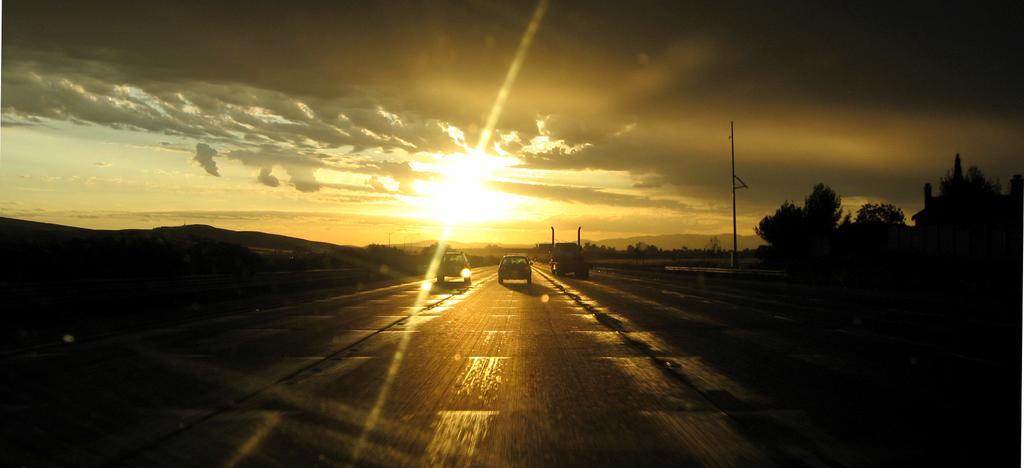Please provide a concise description of this image. In this image, we can see few vehicles are on the road. In the middle of the image, there are so many trees, mountains, pole, house we can see. Top of the image, there is a cloudy sky. 